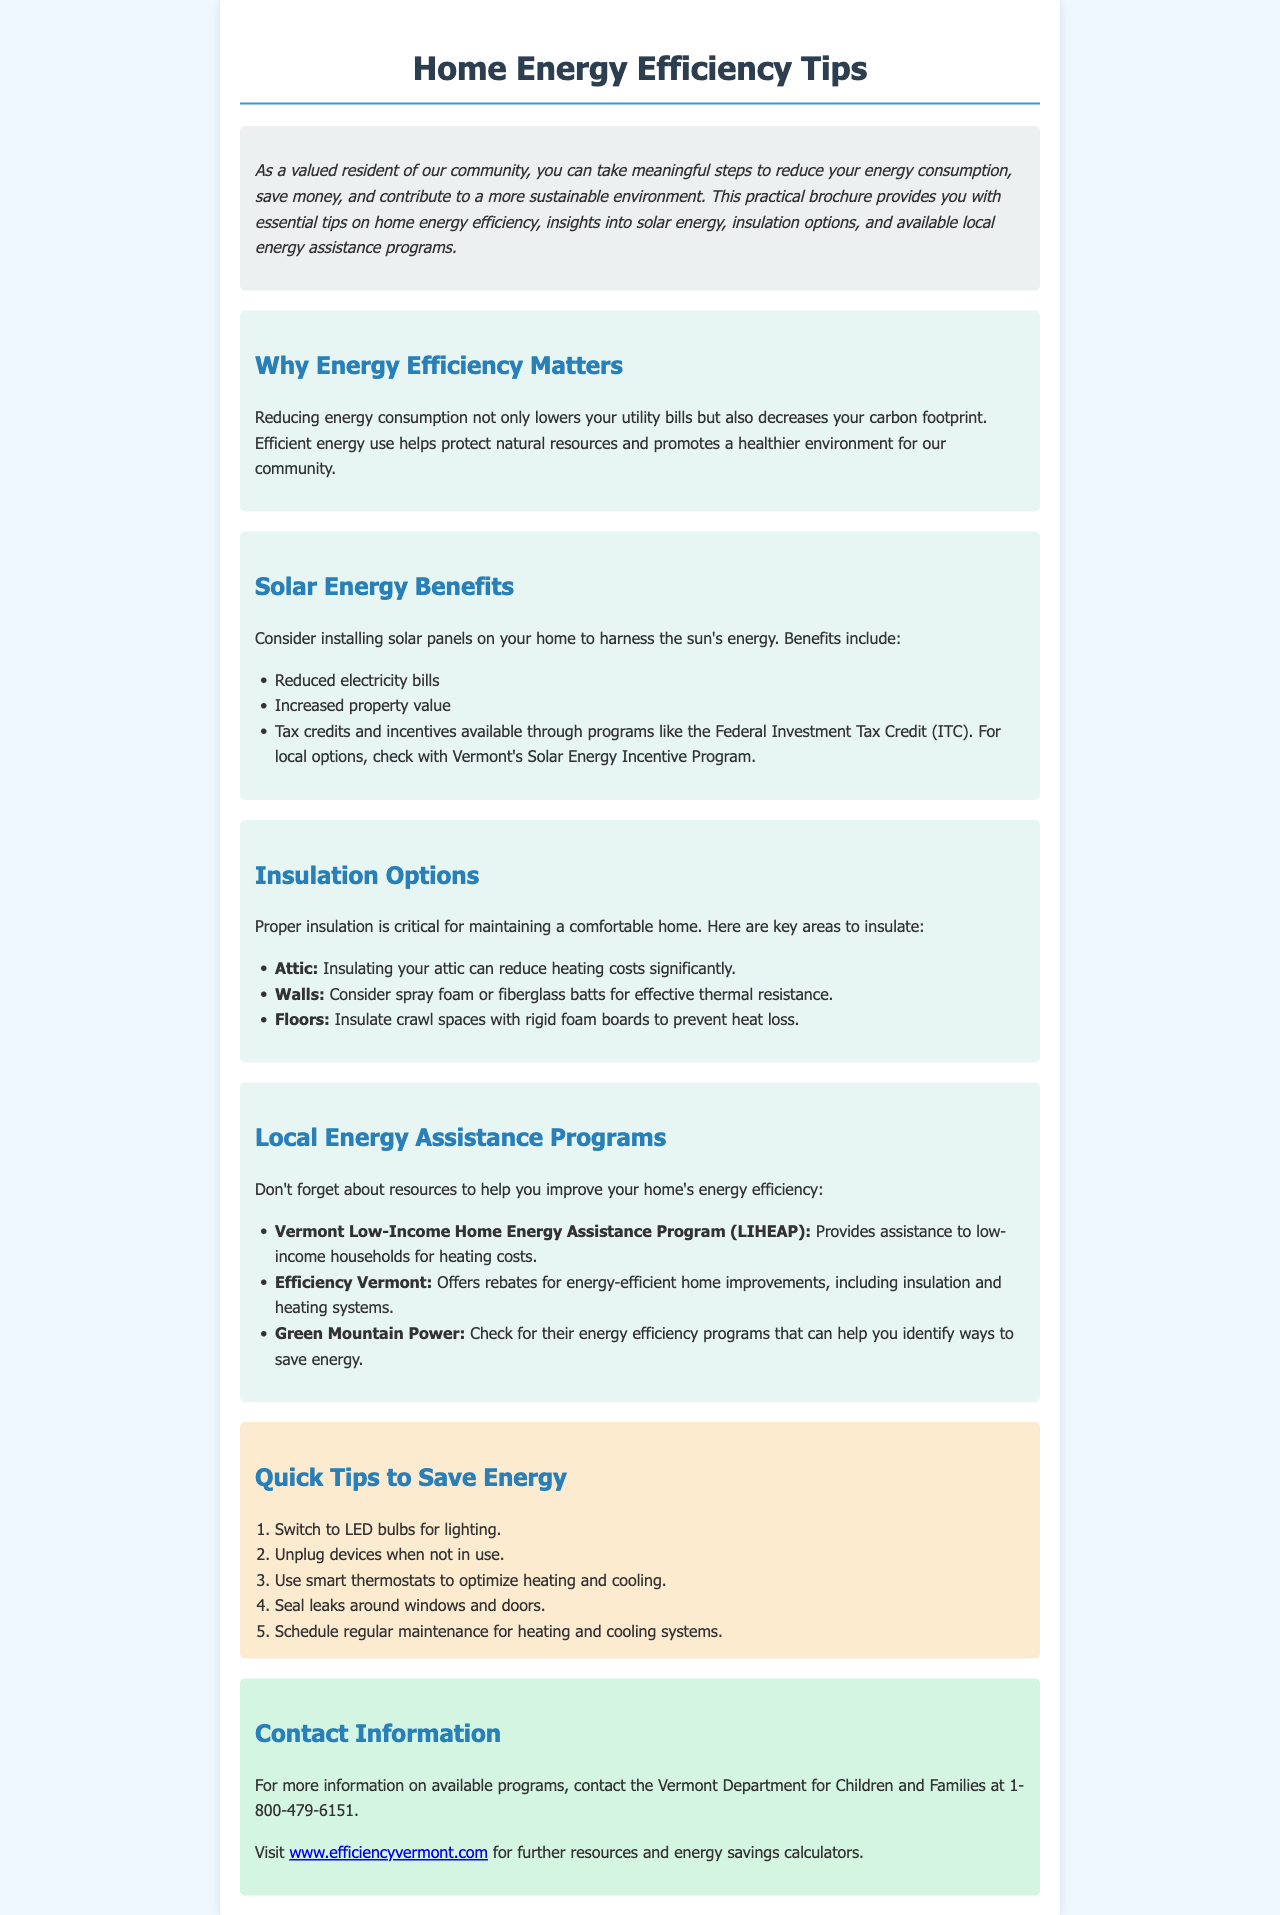what is the title of the brochure? The title is clearly stated in the header section of the document.
Answer: Home Energy Efficiency Tips what program provides assistance to low-income households for heating costs? This information is found in the section detailing local energy assistance programs.
Answer: Vermont Low-Income Home Energy Assistance Program (LIHEAP) what is one benefit of installing solar panels? Benefits of solar panels are listed in the Solar Energy Benefits section.
Answer: Reduced electricity bills which area of the house can insulation significantly reduce heating costs? The answer can be found in the insulation options section.
Answer: Attic how many quick tips are provided to save energy? The number of tips is indicated in the quick tips section of the document.
Answer: Five which organization offers rebates for energy-efficient home improvements? This organization is mentioned in the local energy assistance programs section.
Answer: Efficiency Vermont what color is used for the background of the contact information section? The background color is described in the CSS for the contact info segment.
Answer: Light green (d5f5e3) what is the purpose of using smart thermostats according to the quick tips? The quick tips provide insights into optimizing heating and cooling.
Answer: Optimize heating and cooling what is the phone number for the Vermont Department for Children and Families? The contact information provides this number for further inquiries.
Answer: 1-800-479-6151 